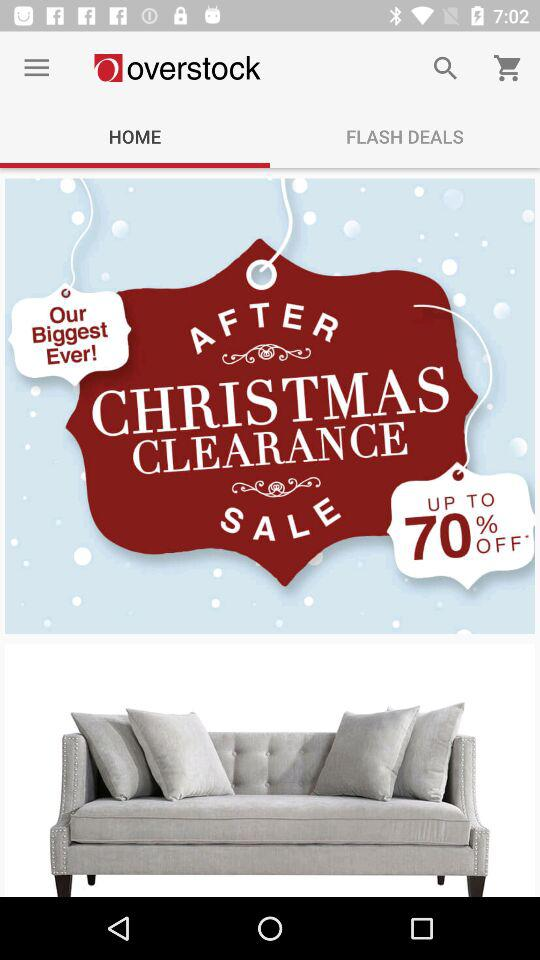What is the discount percentage in the After Christmas Clearance Sale? The discount percentage is up to 70. 